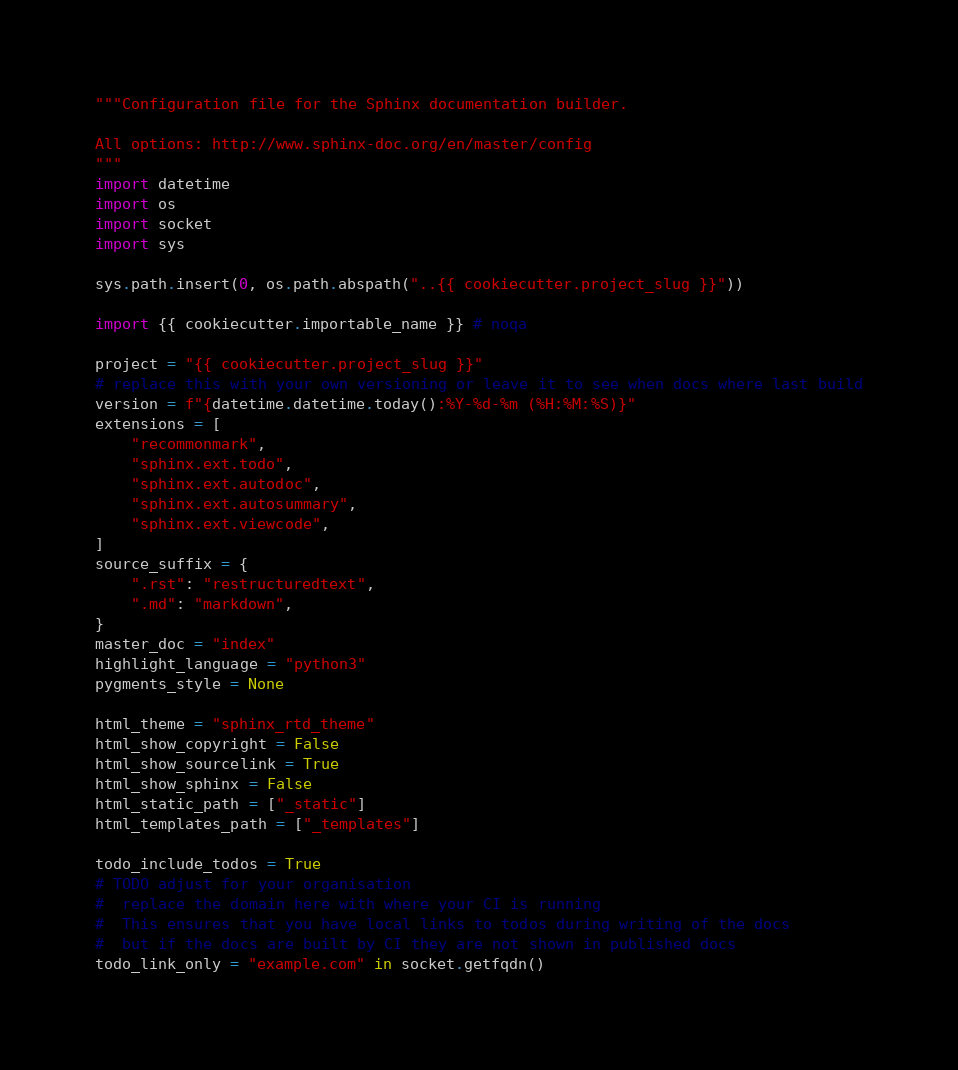Convert code to text. <code><loc_0><loc_0><loc_500><loc_500><_Python_>"""Configuration file for the Sphinx documentation builder.

All options: http://www.sphinx-doc.org/en/master/config
"""
import datetime
import os
import socket
import sys

sys.path.insert(0, os.path.abspath("..{{ cookiecutter.project_slug }}"))

import {{ cookiecutter.importable_name }} # noqa

project = "{{ cookiecutter.project_slug }}"
# replace this with your own versioning or leave it to see when docs where last build
version = f"{datetime.datetime.today():%Y-%d-%m (%H:%M:%S)}"
extensions = [
    "recommonmark",
    "sphinx.ext.todo",
    "sphinx.ext.autodoc",
    "sphinx.ext.autosummary",
    "sphinx.ext.viewcode",
]
source_suffix = {
    ".rst": "restructuredtext",
    ".md": "markdown",
}
master_doc = "index"
highlight_language = "python3"
pygments_style = None

html_theme = "sphinx_rtd_theme"
html_show_copyright = False
html_show_sourcelink = True
html_show_sphinx = False
html_static_path = ["_static"]
html_templates_path = ["_templates"]

todo_include_todos = True
# TODO adjust for your organisation
#  replace the domain here with where your CI is running
#  This ensures that you have local links to todos during writing of the docs
#  but if the docs are built by CI they are not shown in published docs
todo_link_only = "example.com" in socket.getfqdn()
</code> 